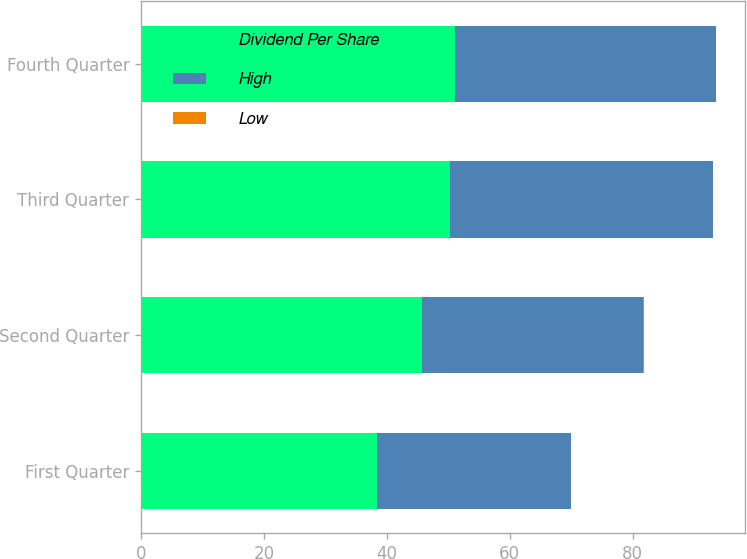Convert chart. <chart><loc_0><loc_0><loc_500><loc_500><stacked_bar_chart><ecel><fcel>First Quarter<fcel>Second Quarter<fcel>Third Quarter<fcel>Fourth Quarter<nl><fcel>Dividend Per Share<fcel>38.43<fcel>45.77<fcel>50.31<fcel>51.13<nl><fcel>High<fcel>31.57<fcel>36<fcel>42.79<fcel>42.43<nl><fcel>Low<fcel>0.04<fcel>0.04<fcel>0.04<fcel>0.04<nl></chart> 